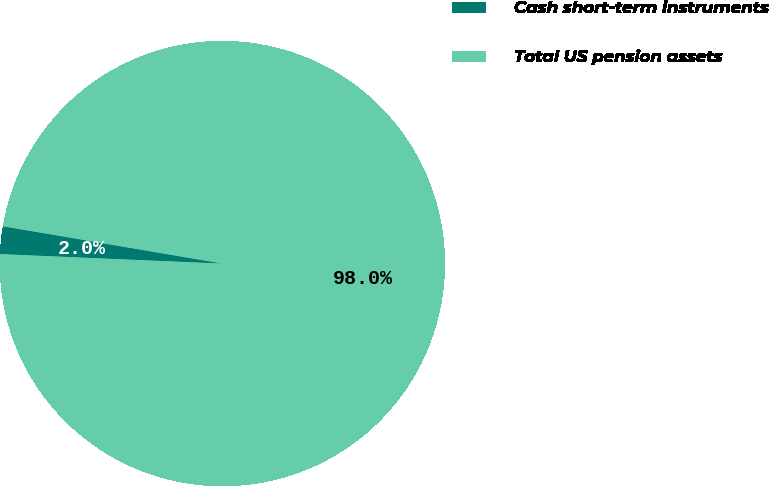<chart> <loc_0><loc_0><loc_500><loc_500><pie_chart><fcel>Cash short-term instruments<fcel>Total US pension assets<nl><fcel>2.0%<fcel>98.0%<nl></chart> 